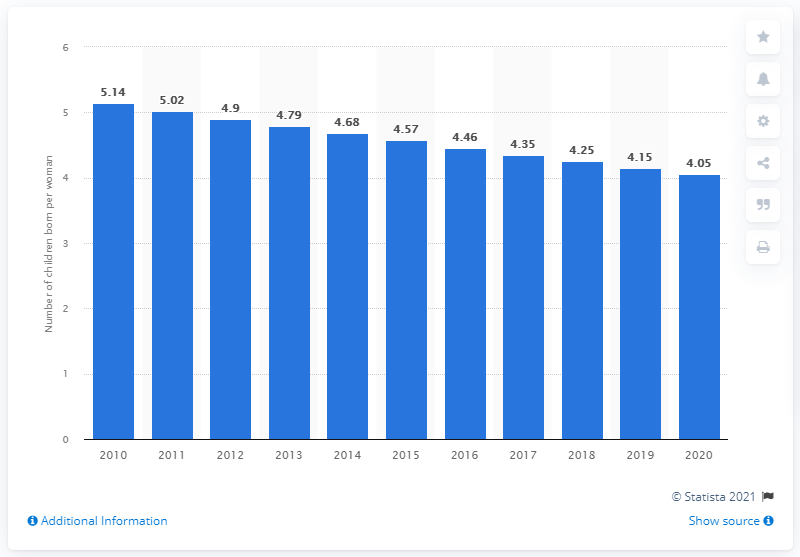List a handful of essential elements in this visual. The fertility rate in Ethiopia in 2020 was 4.05. 